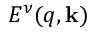Convert formula to latex. <formula><loc_0><loc_0><loc_500><loc_500>E ^ { \nu } ( q , k )</formula> 